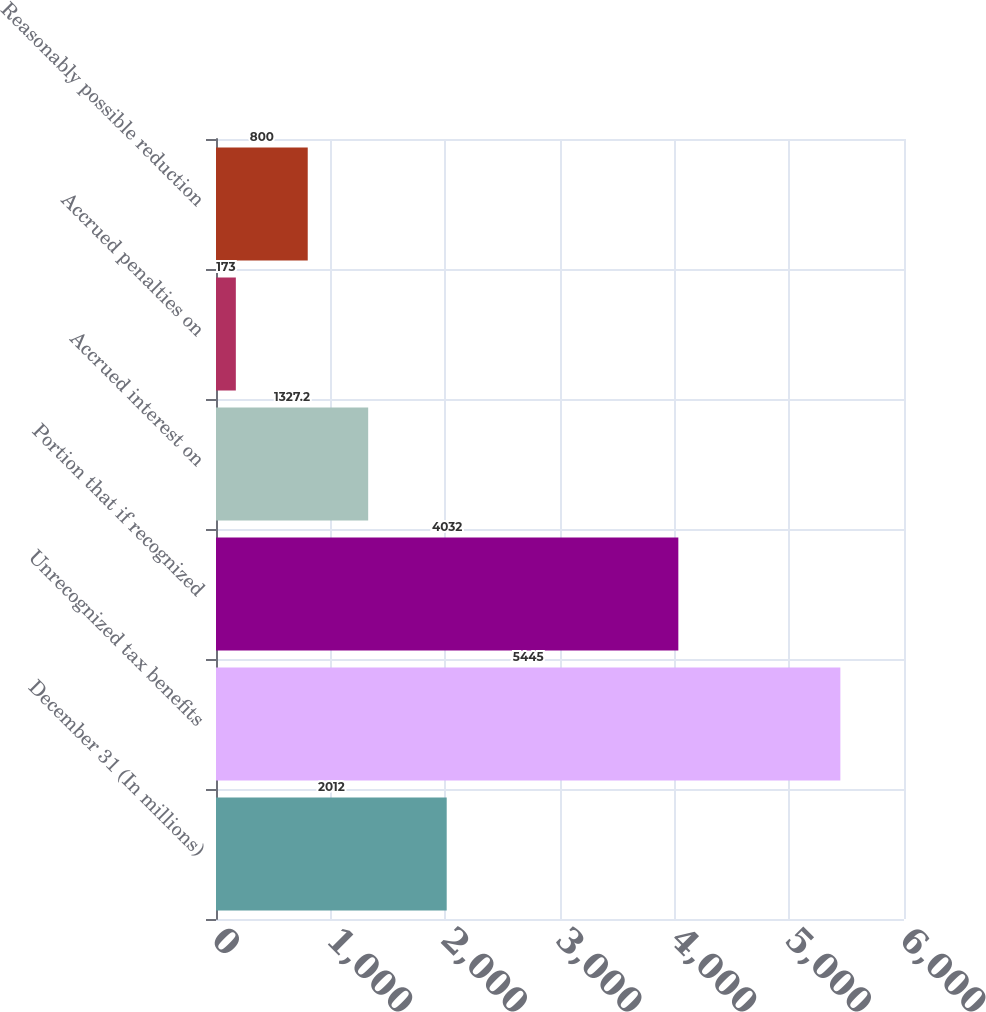<chart> <loc_0><loc_0><loc_500><loc_500><bar_chart><fcel>December 31 (In millions)<fcel>Unrecognized tax benefits<fcel>Portion that if recognized<fcel>Accrued interest on<fcel>Accrued penalties on<fcel>Reasonably possible reduction<nl><fcel>2012<fcel>5445<fcel>4032<fcel>1327.2<fcel>173<fcel>800<nl></chart> 